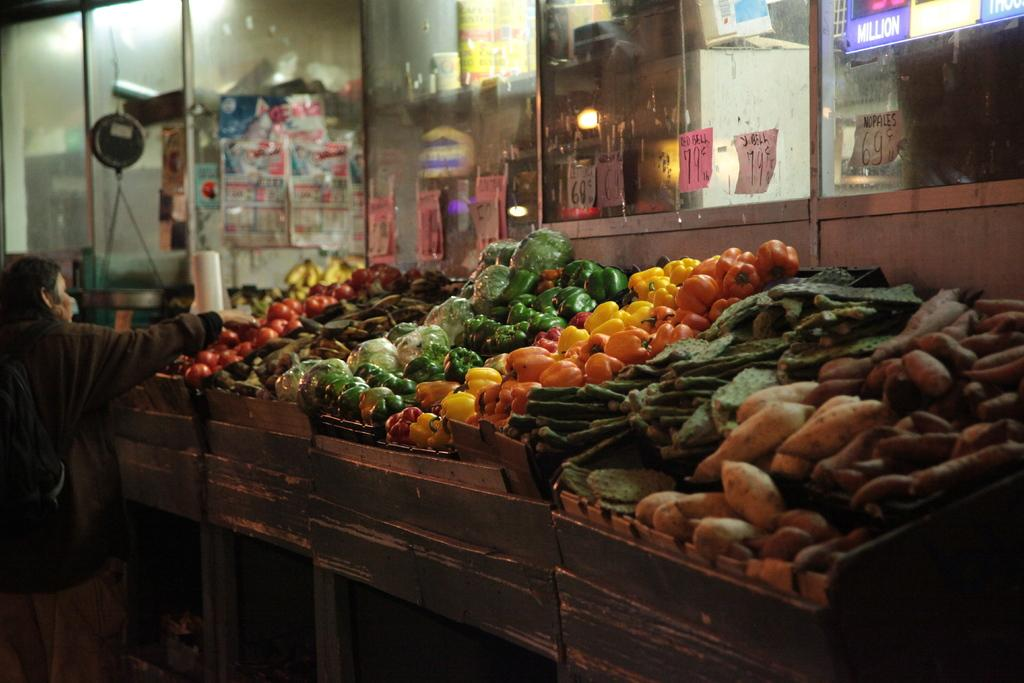What types of vegetables can be seen in the container in the image? There are different varieties of vegetables in the container in the image. What architectural feature is present in the image? There is a glass window in the image. Can you describe the lighting conditions in the image? There is light visible in the image. What object is made of paper in the image? There is a paper in the image. Who is present in the image? There is a person standing in the image. What is the person wearing? The person is wearing clothes. How many babies are crawling on the vegetables in the image? There are no babies present in the image, and the vegetables are in a container, not on the ground. What type of snake can be seen slithering near the person in the image? There are no snakes present in the image. 